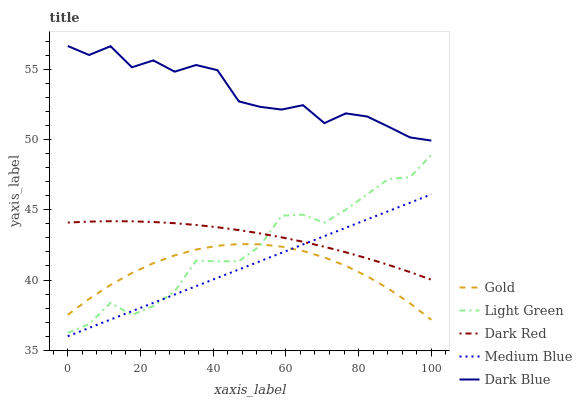Does Gold have the minimum area under the curve?
Answer yes or no. Yes. Does Dark Blue have the maximum area under the curve?
Answer yes or no. Yes. Does Medium Blue have the minimum area under the curve?
Answer yes or no. No. Does Medium Blue have the maximum area under the curve?
Answer yes or no. No. Is Medium Blue the smoothest?
Answer yes or no. Yes. Is Dark Blue the roughest?
Answer yes or no. Yes. Is Light Green the smoothest?
Answer yes or no. No. Is Light Green the roughest?
Answer yes or no. No. Does Medium Blue have the lowest value?
Answer yes or no. Yes. Does Light Green have the lowest value?
Answer yes or no. No. Does Dark Blue have the highest value?
Answer yes or no. Yes. Does Medium Blue have the highest value?
Answer yes or no. No. Is Medium Blue less than Dark Blue?
Answer yes or no. Yes. Is Dark Blue greater than Dark Red?
Answer yes or no. Yes. Does Light Green intersect Medium Blue?
Answer yes or no. Yes. Is Light Green less than Medium Blue?
Answer yes or no. No. Is Light Green greater than Medium Blue?
Answer yes or no. No. Does Medium Blue intersect Dark Blue?
Answer yes or no. No. 